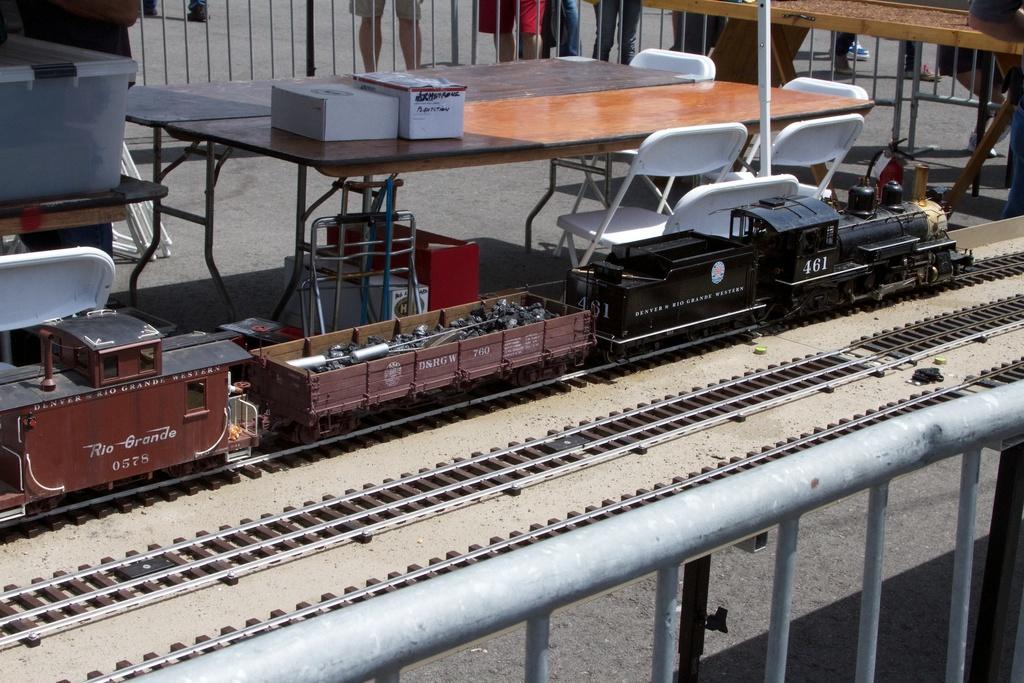Could you give a brief overview of what you see in this image? There is a toy on the railway track, near other two railway tracks and a gray color fencing. In the background, there are chairs arranged around a table, on which, there are two objects, near other chair arranged which is near a table, on which, there is another object, there is a fencing, outside this fencing, there are persons standing on the road. 